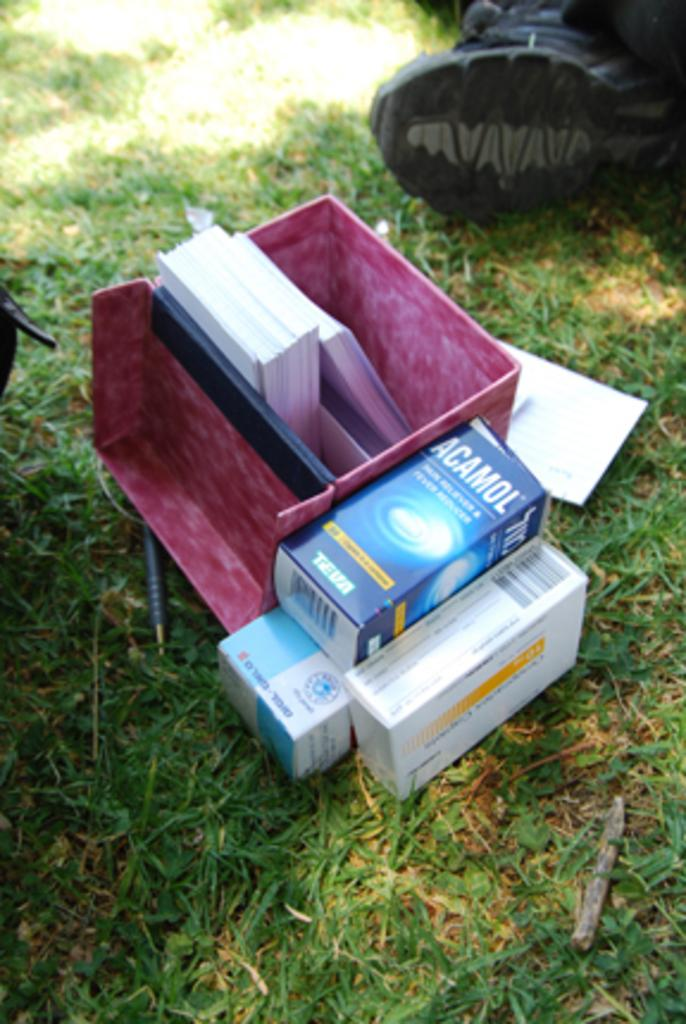What objects are on the ground in the image? There are cardboard boxes on the ground. What type of shoe can be seen in the background? There is a black color shoe in the background. What type of vegetation is visible in the background? There is green-colored grass in the background. Can you find the receipt for the shoe in the image? There is no receipt present in the image. What type of control panel can be seen in the image? There is no control panel present in the image. 